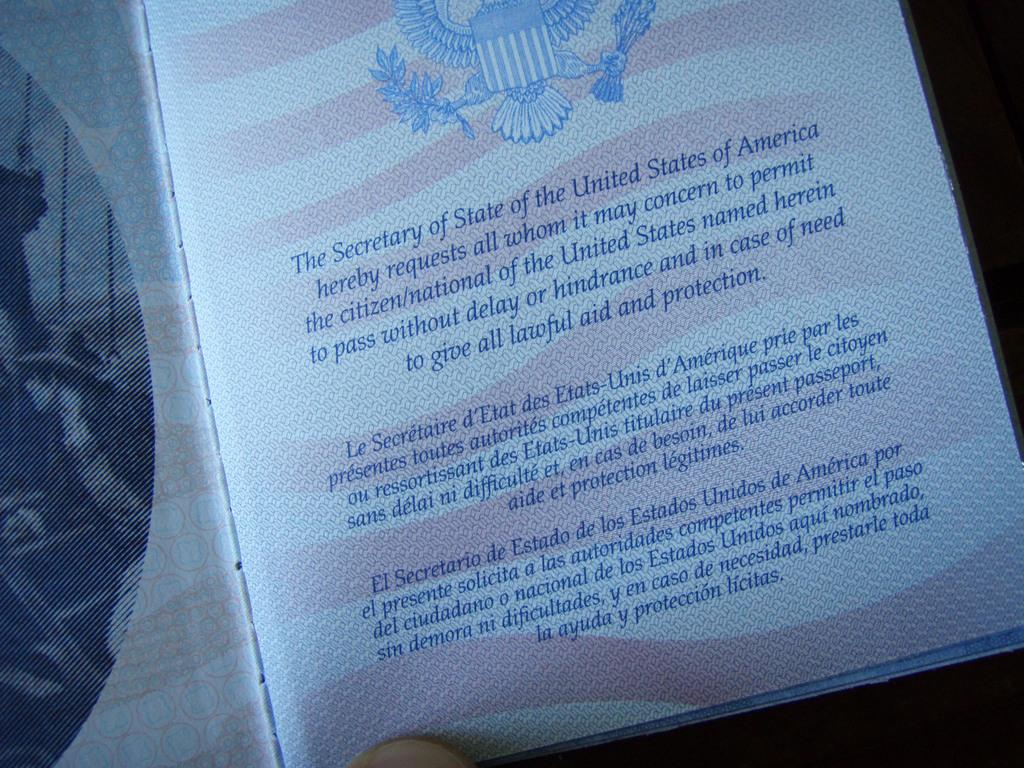What object can be seen in the image? There is a book in the image. What is written on the book? The book has writing on it in blue color. Can you tell me what invention is being discussed in the book? There is no information about the content of the book in the image, so it is impossible to determine what invention might be discussed. 